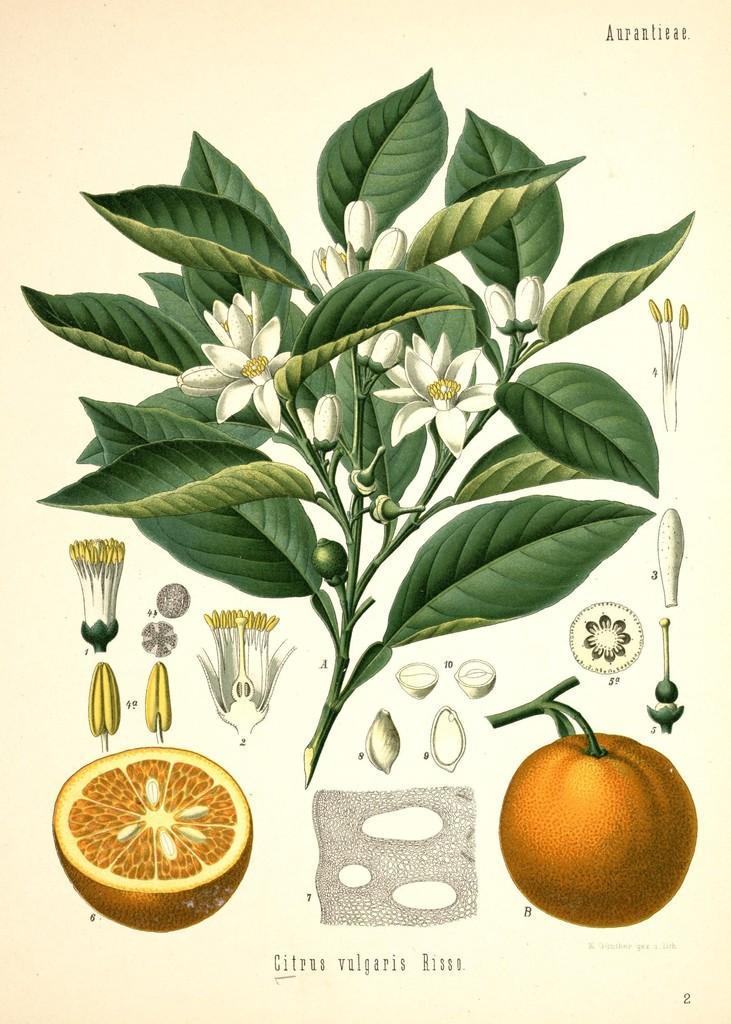How would you summarize this image in a sentence or two? In this picture we can see some leaves, flowers and an orange fruit, on the left side we can see piece of an orange and parts of the flower, there is some text at the bottom. 